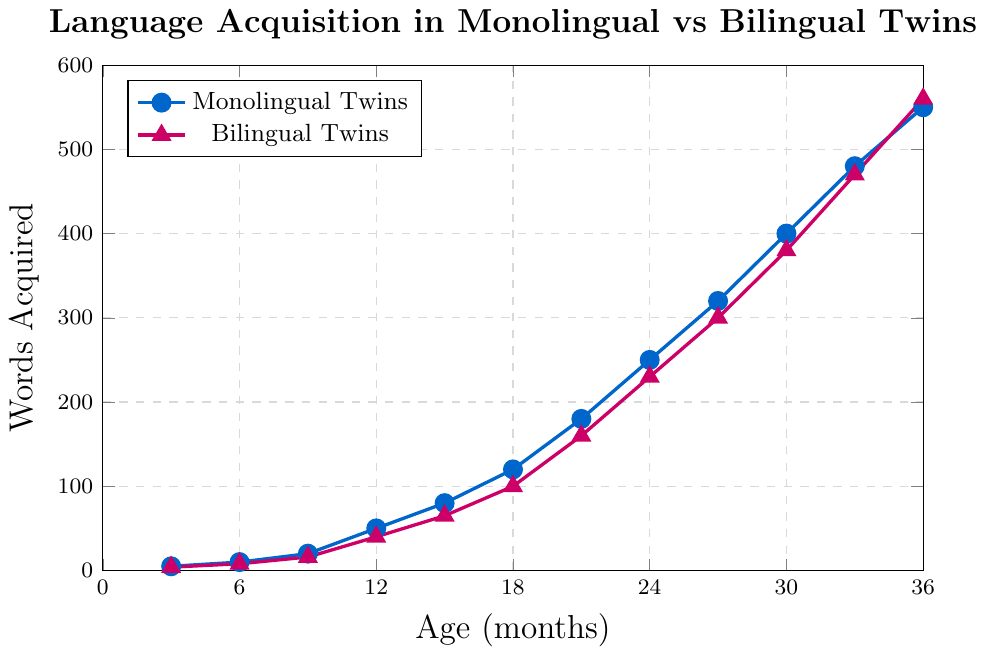What is the number of words acquired by bilingual twins at 24 months? To find this, locate the point where the age is 24 months on the x-axis and follow it up to the mark representing the bilingual twins' words.
Answer: 230 How many more words have monolingual twins acquired compared to bilingual twins at 18 months? Look at the number of words acquired by both groups at 18 months. Monolingual twins have 120 words and bilingual twins have 100 words. Calculate the difference: 120 - 100.
Answer: 20 Which group has a steeper increase in word acquisition between 9 and 12 months? To determine this, compare the slopes of the lines for each group between 9 and 12 months. Monolingual twins' words increase from 20 to 50 and bilingual twins’ words increase from 16 to 40. Calculate the differences (30 for monolingual and 24 for bilingual) and compare.
Answer: Monolingual Twins At what age do bilingual twins have the highest recorded word acquisition in the chart? Locate the maximum y-value on the plot for the bilingual twins, which is the peak point on the red line. Follow this point down to the x-axis age.
Answer: 36 months What is the total number of words acquired by monolingual twins at ages 15, 21, and 27 months? Find the word counts at these ages for monolingual twins: 80 (15 months), 180 (21 months), and 320 (27 months). Sum these counts: 80 + 180 + 320.
Answer: 580 Which age shows the smallest difference in word acquisition between monolingual and bilingual twins? Calculate the word difference at each age: 1 (3 months), 2 (6 months), 4 (9 months), 10 (12 months), 15 (15 months), 20 (18 months), 20 (21 months), 20 (24 months), 20 (27 months), 20 (30 months), 10 (33 months), -10 (36 months). Find the smallest absolute difference.
Answer: 3 months What pattern can be observed in the difference of word acquisition as the twins age from 3 to 36 months? Analyze how the differences evolve over time. Initially, the difference is small but grows slightly, reaching a consistent range (~20 words difference) and eventually converging.
Answer: Initially small, then steady, converges at 36 months By how many words do monolingual twins' word acquisition increase between 12 and 36 months? Look at the words acquired at these points: 50 at 12 months and 550 at 36 months. Subtract to find the difference: 550 - 50.
Answer: 500 